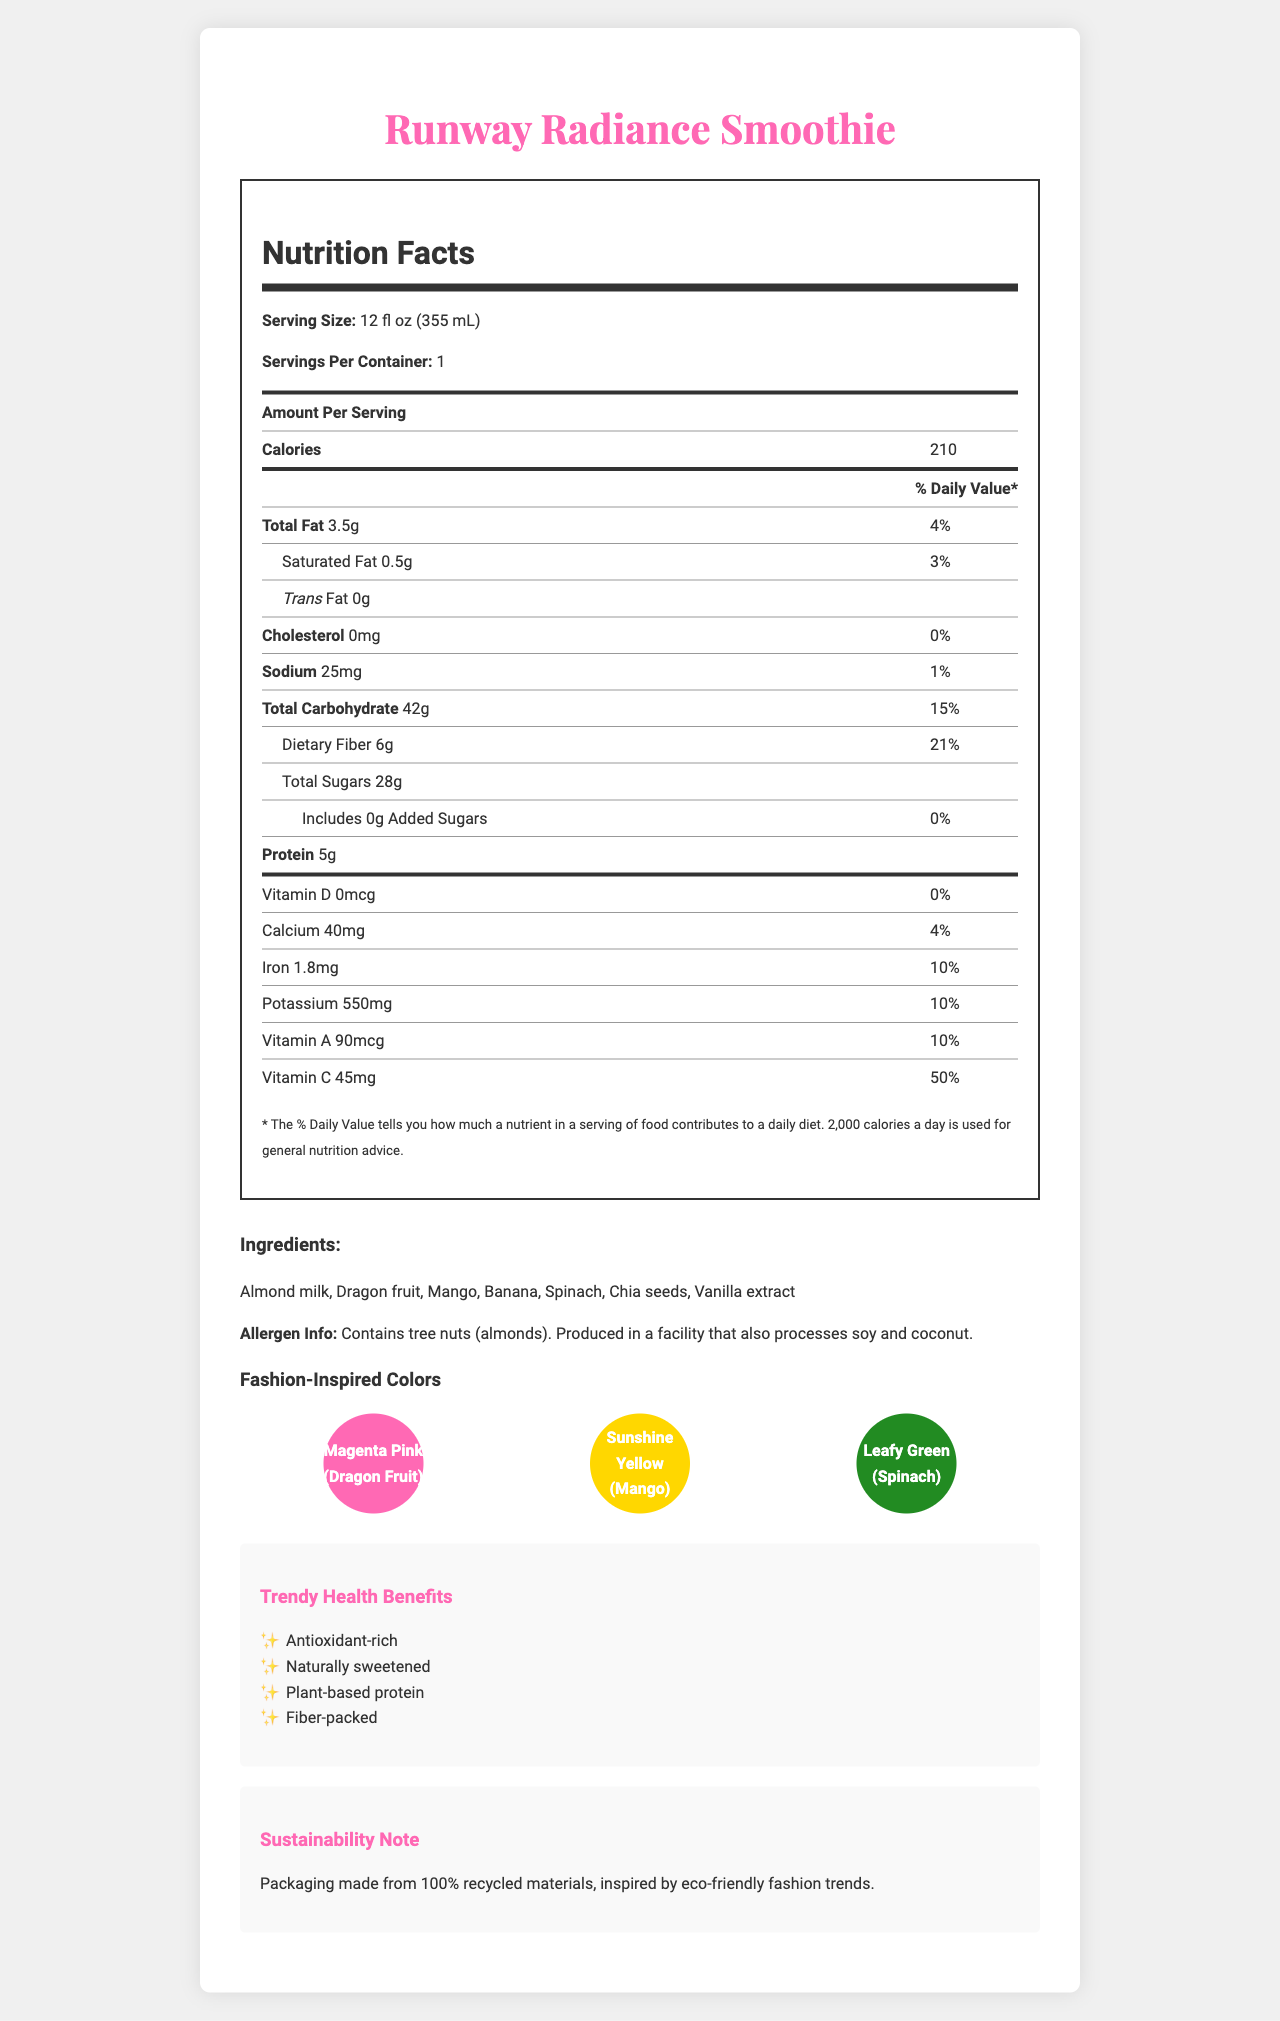what is the product name? The product name is prominently displayed at the top of the nutrition facts document.
Answer: Runway Radiance Smoothie what is the serving size of the smoothie? The serving size is mentioned right after the product name under the "Nutrition Facts" section.
Answer: 12 fl oz (355 mL) how many calories are there per serving? The number of calories per serving is listed under the "Amount Per Serving" header in the nutrition label.
Answer: 210 what is the amount of total fat per serving? The total fat amount per serving is listed under the "Amount Per Serving" section.
Answer: 3.5g what are the main ingredients of the smoothie? The ingredients are listed under the "Ingredients" section of the document.
Answer: Almond milk, Dragon fruit, Mango, Banana, Spinach, Chia seeds, Vanilla extract what is the allergen information for this smoothie? The allergen information is found in the "Allergen Info" section just below the list of ingredients.
Answer: Contains tree nuts (almonds). Produced in a facility that also processes soy and coconut. what is the notable vitamin C contribution per serving? The amount of vitamin C is listed under the nutrition facts table, showing it contributes 50% of the daily value.
Answer: 45mg (50%) which of the following colors are inspired by the ingredients in the smoothie? (A) Ocean Blue (B) Magenta Pink (C) Sunshine Yellow (D) Leafy Green The colors inspired by the ingredients are Magenta Pink (dragon fruit), Sunshine Yellow (mango), and Leafy Green (spinach).
Answer: B, C, D how much protein is there per serving? The protein amount per serving is listed under the "Amount Per Serving" section in the nutrition facts label.
Answer: 5g is the smoothie plant-based? The document lists "Plant-based protein" under the "Trendy Health Benefits" section.
Answer: Yes does the packaging have any sustainability features? The document mentions that the packaging is made from 100% recycled materials, inspired by eco-friendly fashion trends.
Answer: Yes what colors are represented by the ingredients dragon fruit, mango, and spinach? These colors are highlighted in the "Fashion-Inspired Colors" section, associated with their respective ingredients.
Answer: Magenta Pink, Sunshine Yellow, Leafy Green what percentage of daily dietary fiber does one serving provide? The percentage of daily dietary fiber is listed in the nutrition facts under "Total Carbohydrate".
Answer: 21% what are the trendy health benefits of this smoothie? These trendy health benefits are listed under the "Trendy Health Benefits" section.
Answer: Antioxidant-rich, Naturally sweetened, Plant-based protein, Fiber-packed how much added sugar is present in the smoothie? The amount of added sugars is specified in the nutrition facts, showing it is 0g.
Answer: 0g summarize the document. The document aims to inform about the nutritional content and health benefits of the smoothie while aligning its appeal with trendy fashion-inspired elements and sustainability.
Answer: The document provides detailed information about the Runway Radiance Smoothie, including its nutritional facts, ingredients, allergen information, fashion-inspired colors, trendy health benefits, and sustainability notes. It highlights the smoothie as a healthy, vibrant, and eco-friendly choice, enriched with antioxidants, plant-based protein, and fiber. which ingredient is responsible for the Sunshine Yellow color mentioned in the document? The "Fashion-Inspired Colors" section links Sunshine Yellow to mango.
Answer: Mango what facility processes might affect this smoothie? The document only mentions that the smoothie is produced in a facility that also processes soy and coconut but does not detail specific processes.
Answer: Not enough information which ingredient provides a significant source of calcium according to the document? The document provides the calcium content but does not specify which ingredient is the source of that calcium.
Answer: I don't know 